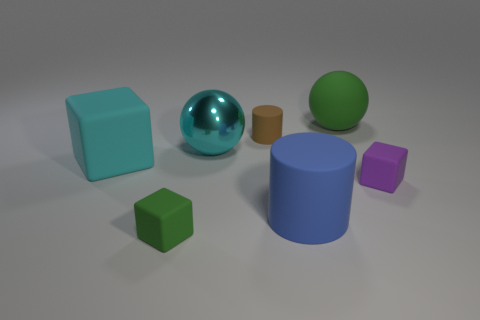The big rubber object that is to the left of the tiny rubber block that is left of the rubber block that is on the right side of the large rubber sphere is what color?
Provide a succinct answer. Cyan. There is a tiny cube that is on the left side of the tiny purple block; is it the same color as the sphere right of the cyan metallic object?
Provide a succinct answer. Yes. Is there anything else that has the same color as the big metallic thing?
Your answer should be very brief. Yes. Are there fewer matte spheres in front of the cyan metal thing than blue cylinders?
Your answer should be very brief. Yes. What number of rubber cylinders are there?
Provide a succinct answer. 2. There is a cyan metal thing; is its shape the same as the green thing behind the cyan matte block?
Offer a very short reply. Yes. Are there fewer cubes in front of the big cylinder than matte objects that are in front of the tiny cylinder?
Your response must be concise. Yes. Is there anything else that is the same shape as the purple rubber object?
Provide a short and direct response. Yes. Does the large cyan rubber thing have the same shape as the purple matte object?
Make the answer very short. Yes. Are there any other things that have the same material as the big cyan ball?
Offer a terse response. No. 